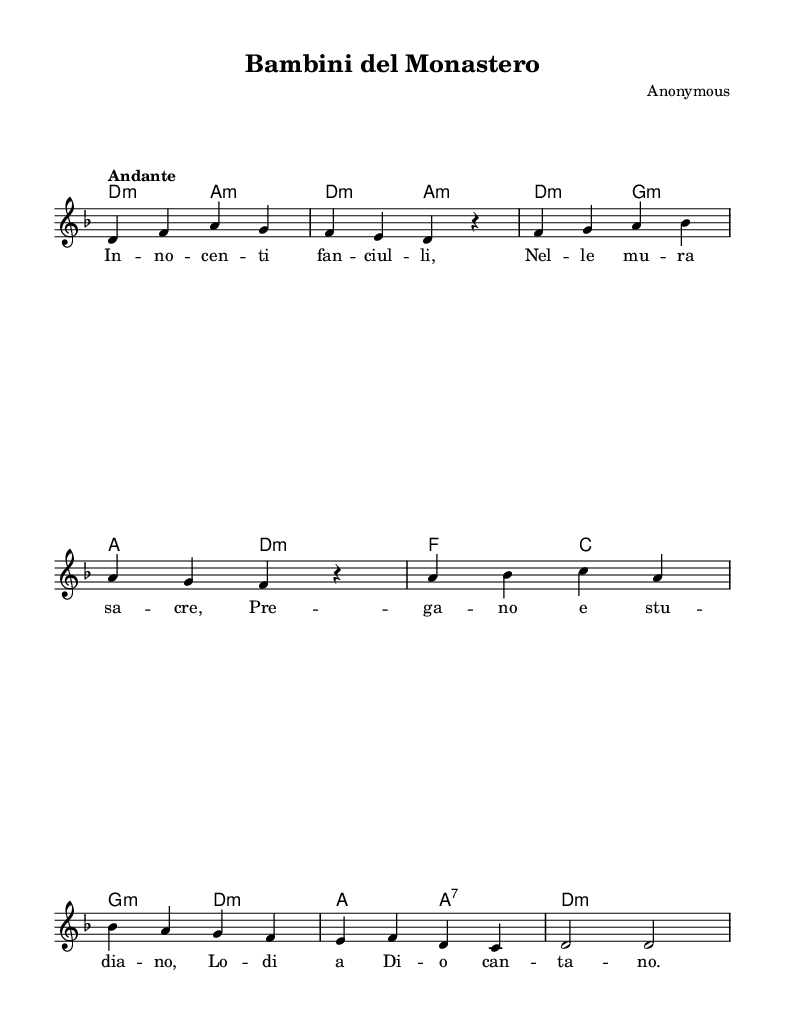What is the key signature of this music? The key signature is D minor, which includes one flat (B flat). We can determine this by looking at the key signature indicated at the beginning of the score.
Answer: D minor What is the time signature of this piece? The time signature is 4/4, which indicates there are four beats in each measure and the quarter note gets one beat. This is shown at the beginning of the score.
Answer: 4/4 What is the tempo marking for the piece? The tempo marking is "Andante," which is a moderate pace indicating a walking speed. This is noted above the staff in the score.
Answer: Andante How many measures are in the melody? There are eight measures in the melody, which can be counted by examining the individual segments divided by the bar lines present in the score.
Answer: Eight What is the final note of the melody? The final note of the melody is D, which we can identify by looking at the last note in the staff of the melody section.
Answer: D Is there a specific cultural or religious significance found in the lyrics? Yes, the lyrics reflect a religious theme, focusing on children in monastic life and their dedication to God in prayer and study. This can be inferred from the content of the lyrics themselves, which talk about praying and singing to God.
Answer: Yes What type of musical texture is present in this hymn? The texture is homophonic, characterized by a single melodic line supported by chordal harmony. This is evident from the structure where the melody is clearly distinguishable from the accompanying chords.
Answer: Homophonic 